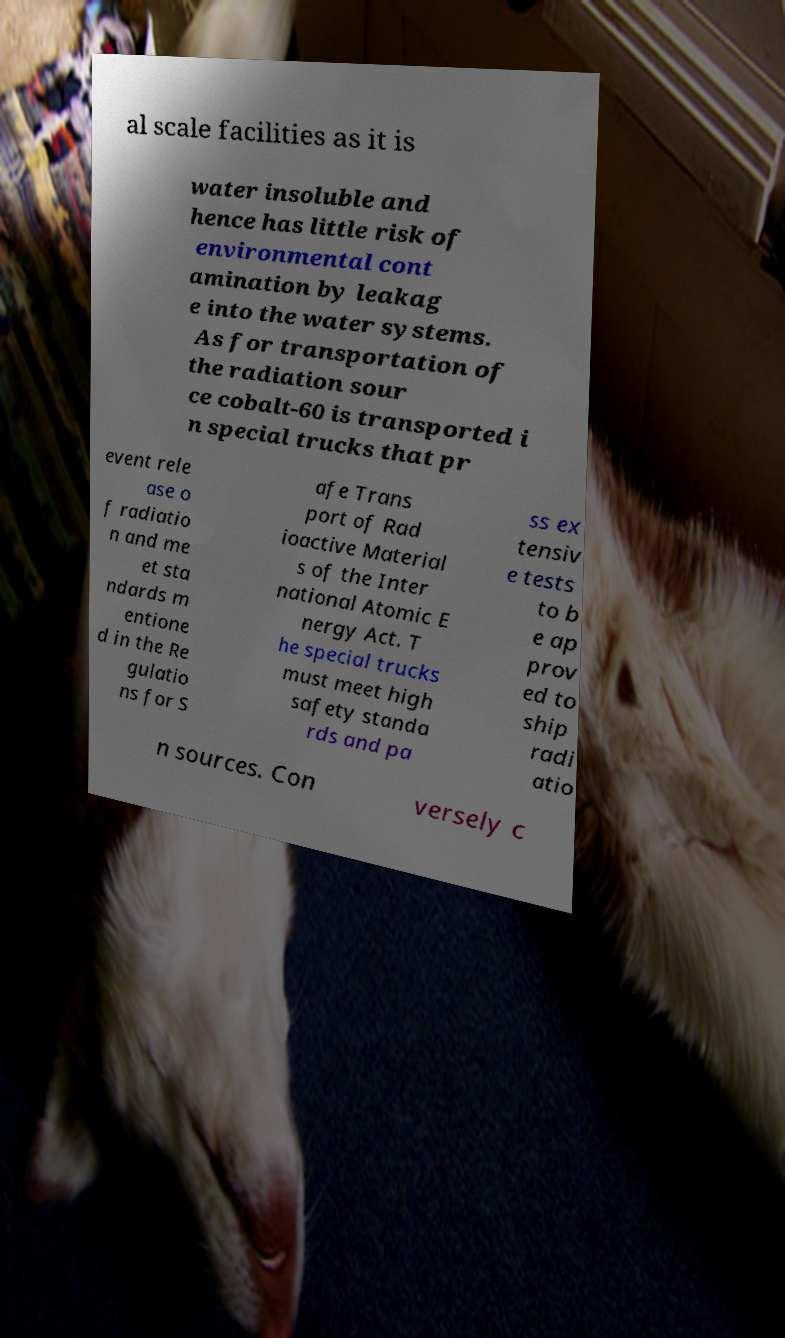Could you assist in decoding the text presented in this image and type it out clearly? al scale facilities as it is water insoluble and hence has little risk of environmental cont amination by leakag e into the water systems. As for transportation of the radiation sour ce cobalt-60 is transported i n special trucks that pr event rele ase o f radiatio n and me et sta ndards m entione d in the Re gulatio ns for S afe Trans port of Rad ioactive Material s of the Inter national Atomic E nergy Act. T he special trucks must meet high safety standa rds and pa ss ex tensiv e tests to b e ap prov ed to ship radi atio n sources. Con versely c 